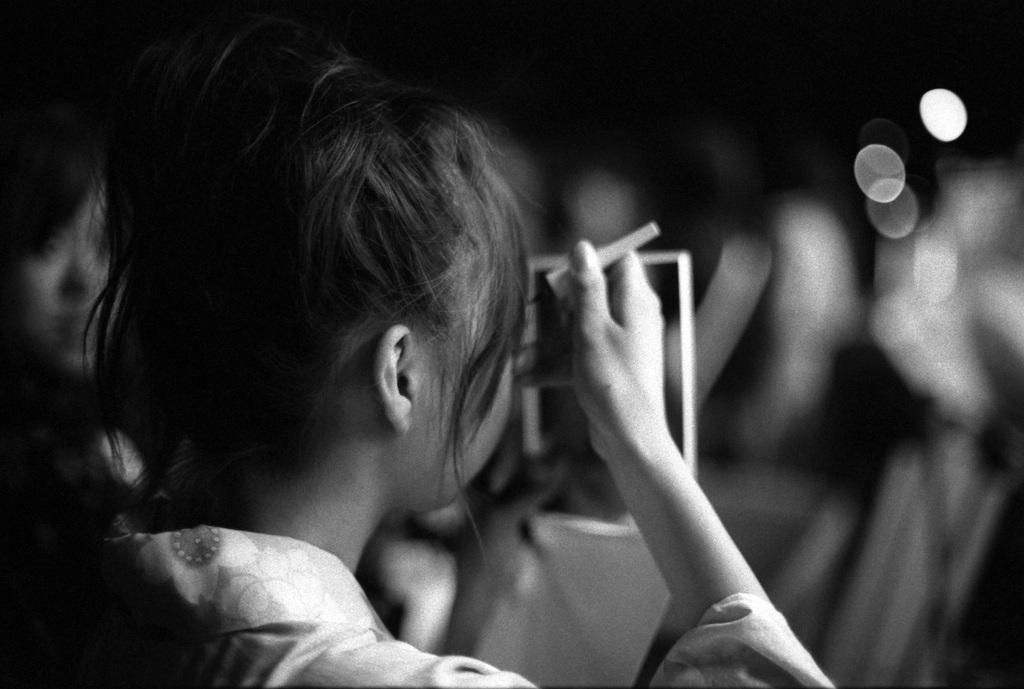Please provide a concise description of this image. It is the black and white image in which there is a woman who is keeping the kajal to her eyes by looking in to the mirror which is in front of her. 